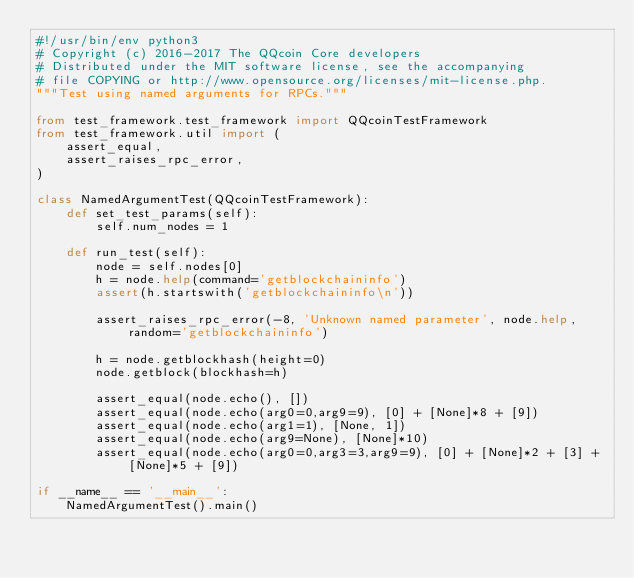<code> <loc_0><loc_0><loc_500><loc_500><_Python_>#!/usr/bin/env python3
# Copyright (c) 2016-2017 The QQcoin Core developers
# Distributed under the MIT software license, see the accompanying
# file COPYING or http://www.opensource.org/licenses/mit-license.php.
"""Test using named arguments for RPCs."""

from test_framework.test_framework import QQcoinTestFramework
from test_framework.util import (
    assert_equal,
    assert_raises_rpc_error,
)

class NamedArgumentTest(QQcoinTestFramework):
    def set_test_params(self):
        self.num_nodes = 1

    def run_test(self):
        node = self.nodes[0]
        h = node.help(command='getblockchaininfo')
        assert(h.startswith('getblockchaininfo\n'))

        assert_raises_rpc_error(-8, 'Unknown named parameter', node.help, random='getblockchaininfo')

        h = node.getblockhash(height=0)
        node.getblock(blockhash=h)

        assert_equal(node.echo(), [])
        assert_equal(node.echo(arg0=0,arg9=9), [0] + [None]*8 + [9])
        assert_equal(node.echo(arg1=1), [None, 1])
        assert_equal(node.echo(arg9=None), [None]*10)
        assert_equal(node.echo(arg0=0,arg3=3,arg9=9), [0] + [None]*2 + [3] + [None]*5 + [9])

if __name__ == '__main__':
    NamedArgumentTest().main()
</code> 